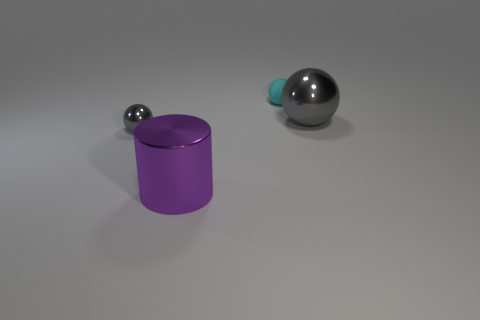Subtract all red spheres. Subtract all red blocks. How many spheres are left? 3 Add 1 purple metal cylinders. How many objects exist? 5 Subtract all balls. How many objects are left? 1 Add 1 large metallic balls. How many large metallic balls exist? 2 Subtract 0 yellow cubes. How many objects are left? 4 Subtract all tiny cyan rubber cubes. Subtract all cyan spheres. How many objects are left? 3 Add 2 small cyan things. How many small cyan things are left? 3 